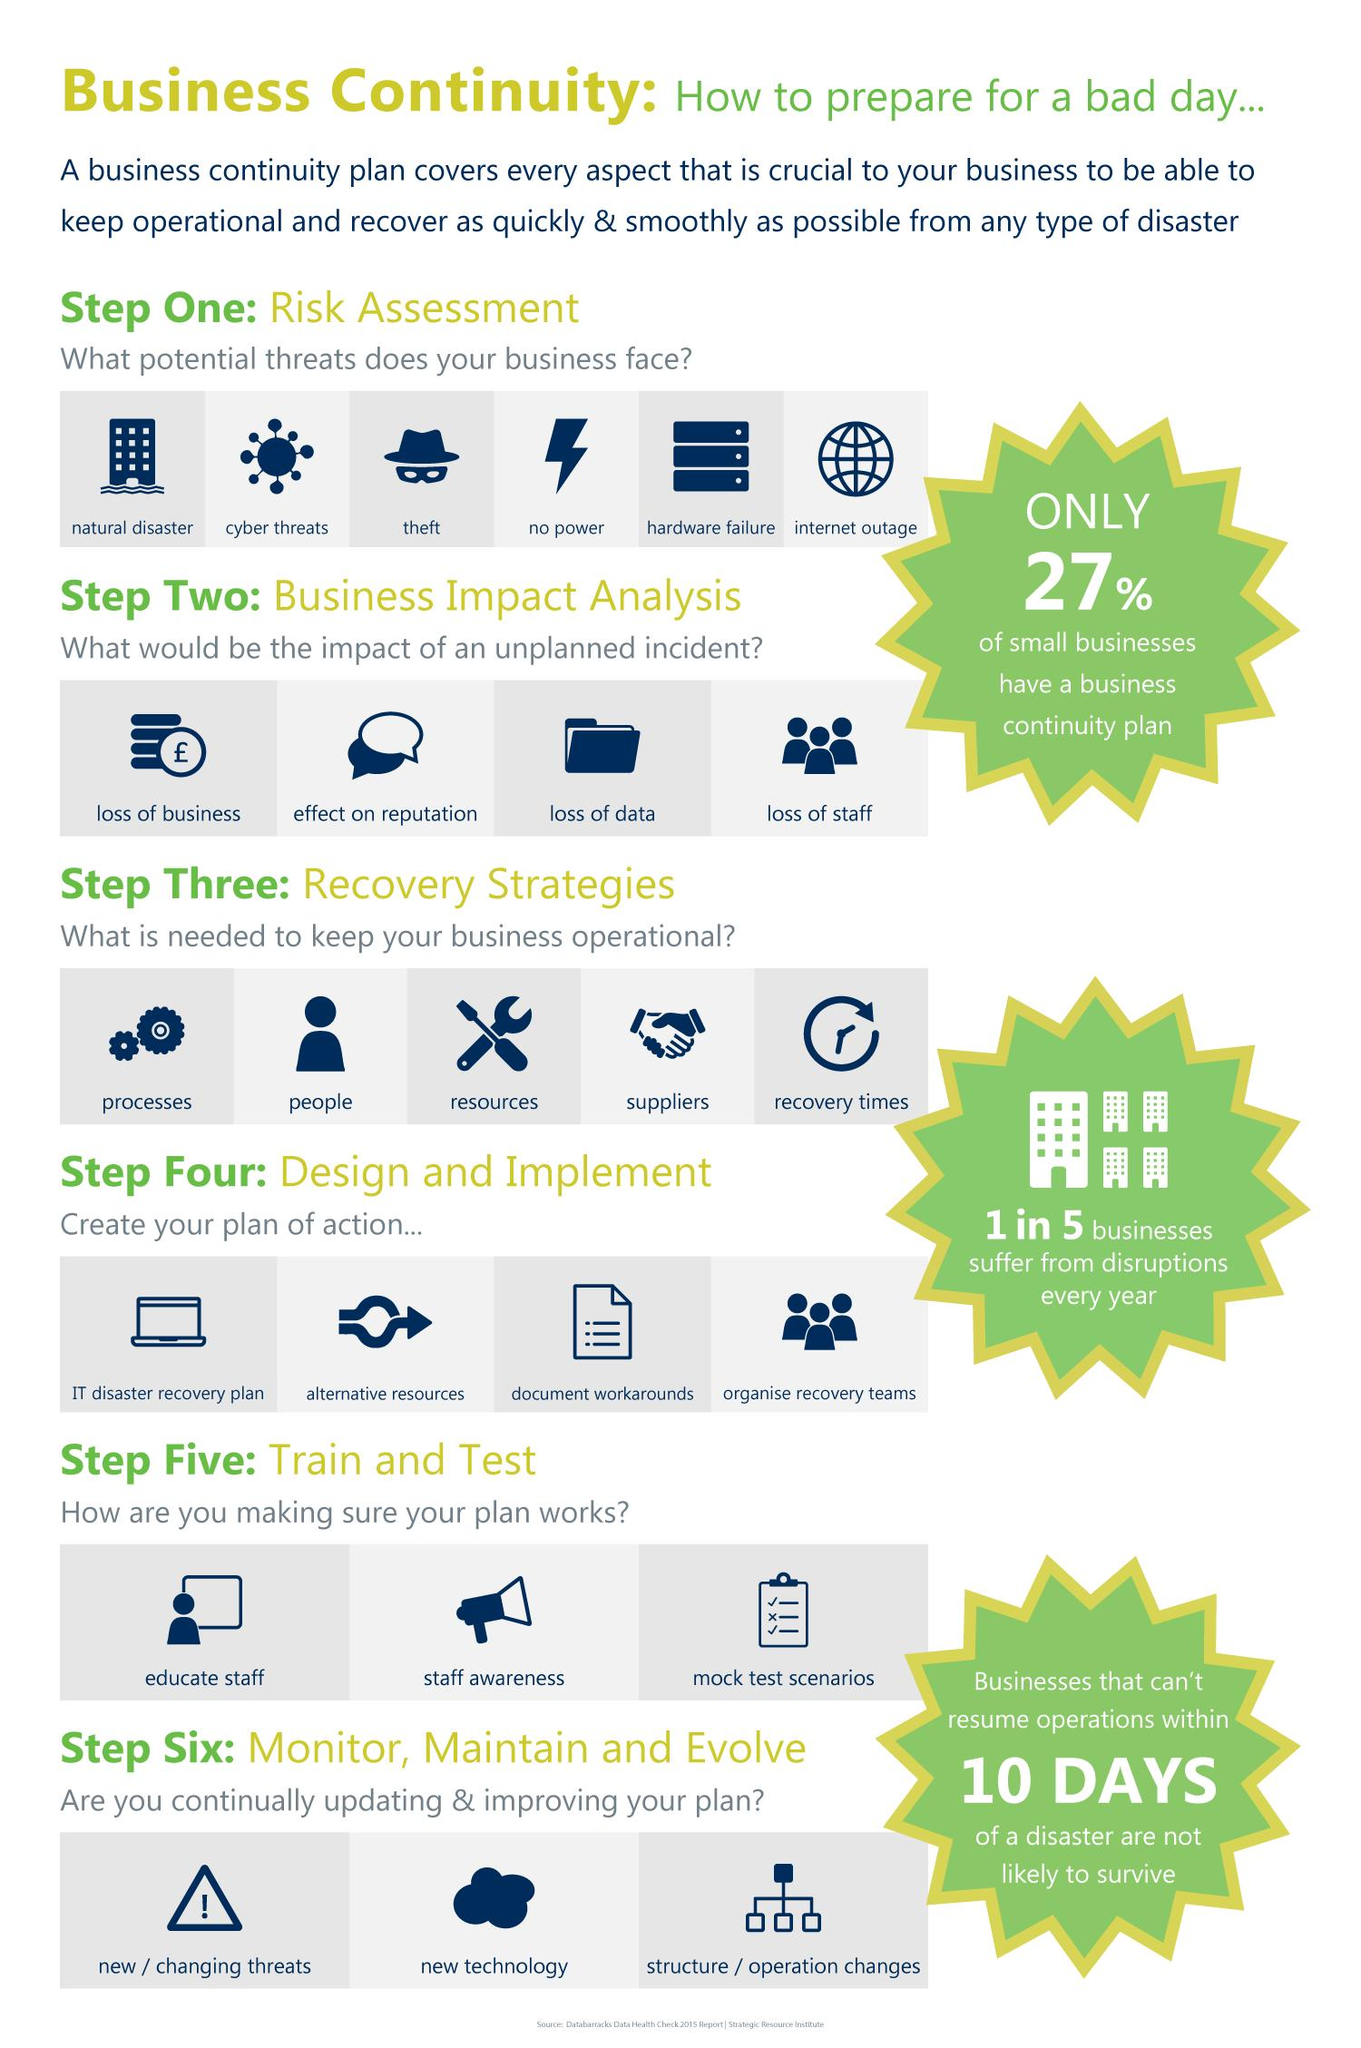Identify some key points in this picture. The impact of an unplanned incident that is listed as the second effect on reputation. The potential threat of theft is listed third among the concerns faced by businesses. The primary step taken when designing an action plan for IT disaster recovery is the creation of the plan itself. A recent study found that 73% of small businesses do not have a business continuity plan in place, meaning they do not have a plan in place to continue their operations in the event of a disaster or other disruptive event. To effectively create an action plan and facilitate recovery efforts, the fourth step involves organizing recovery teams. 